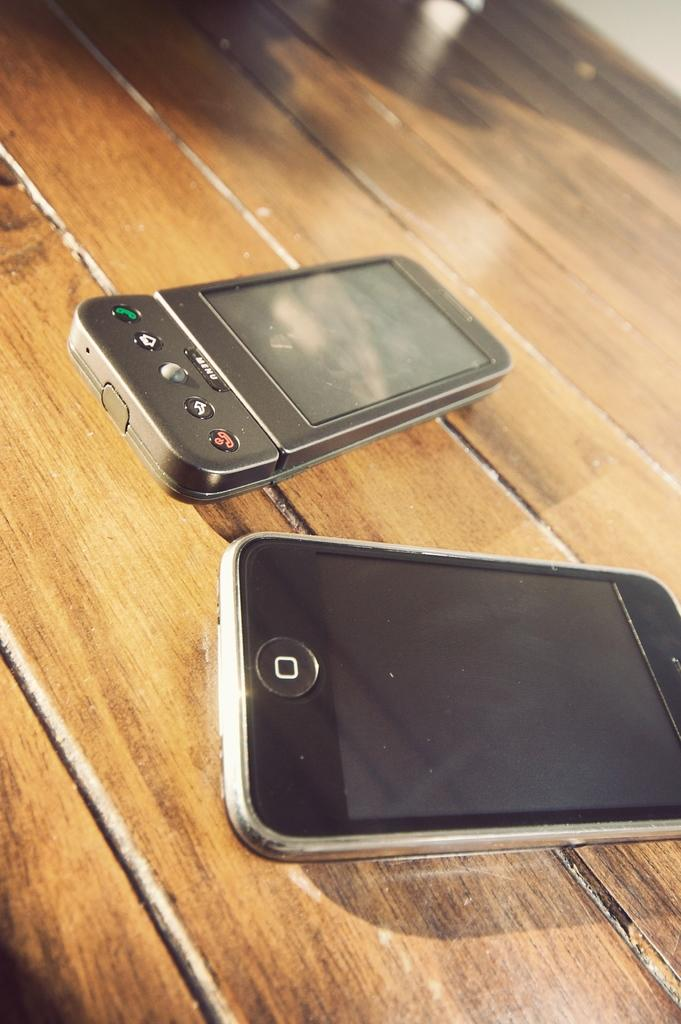What type of table is in the image? There is a wooden table in the image. What objects are on the table? There are two mobiles on the table. How are the mobiles positioned on the table? The mobiles are placed beside each other. What type of book is floating in the air in the image? There is no book or any object floating in the air in the image. 